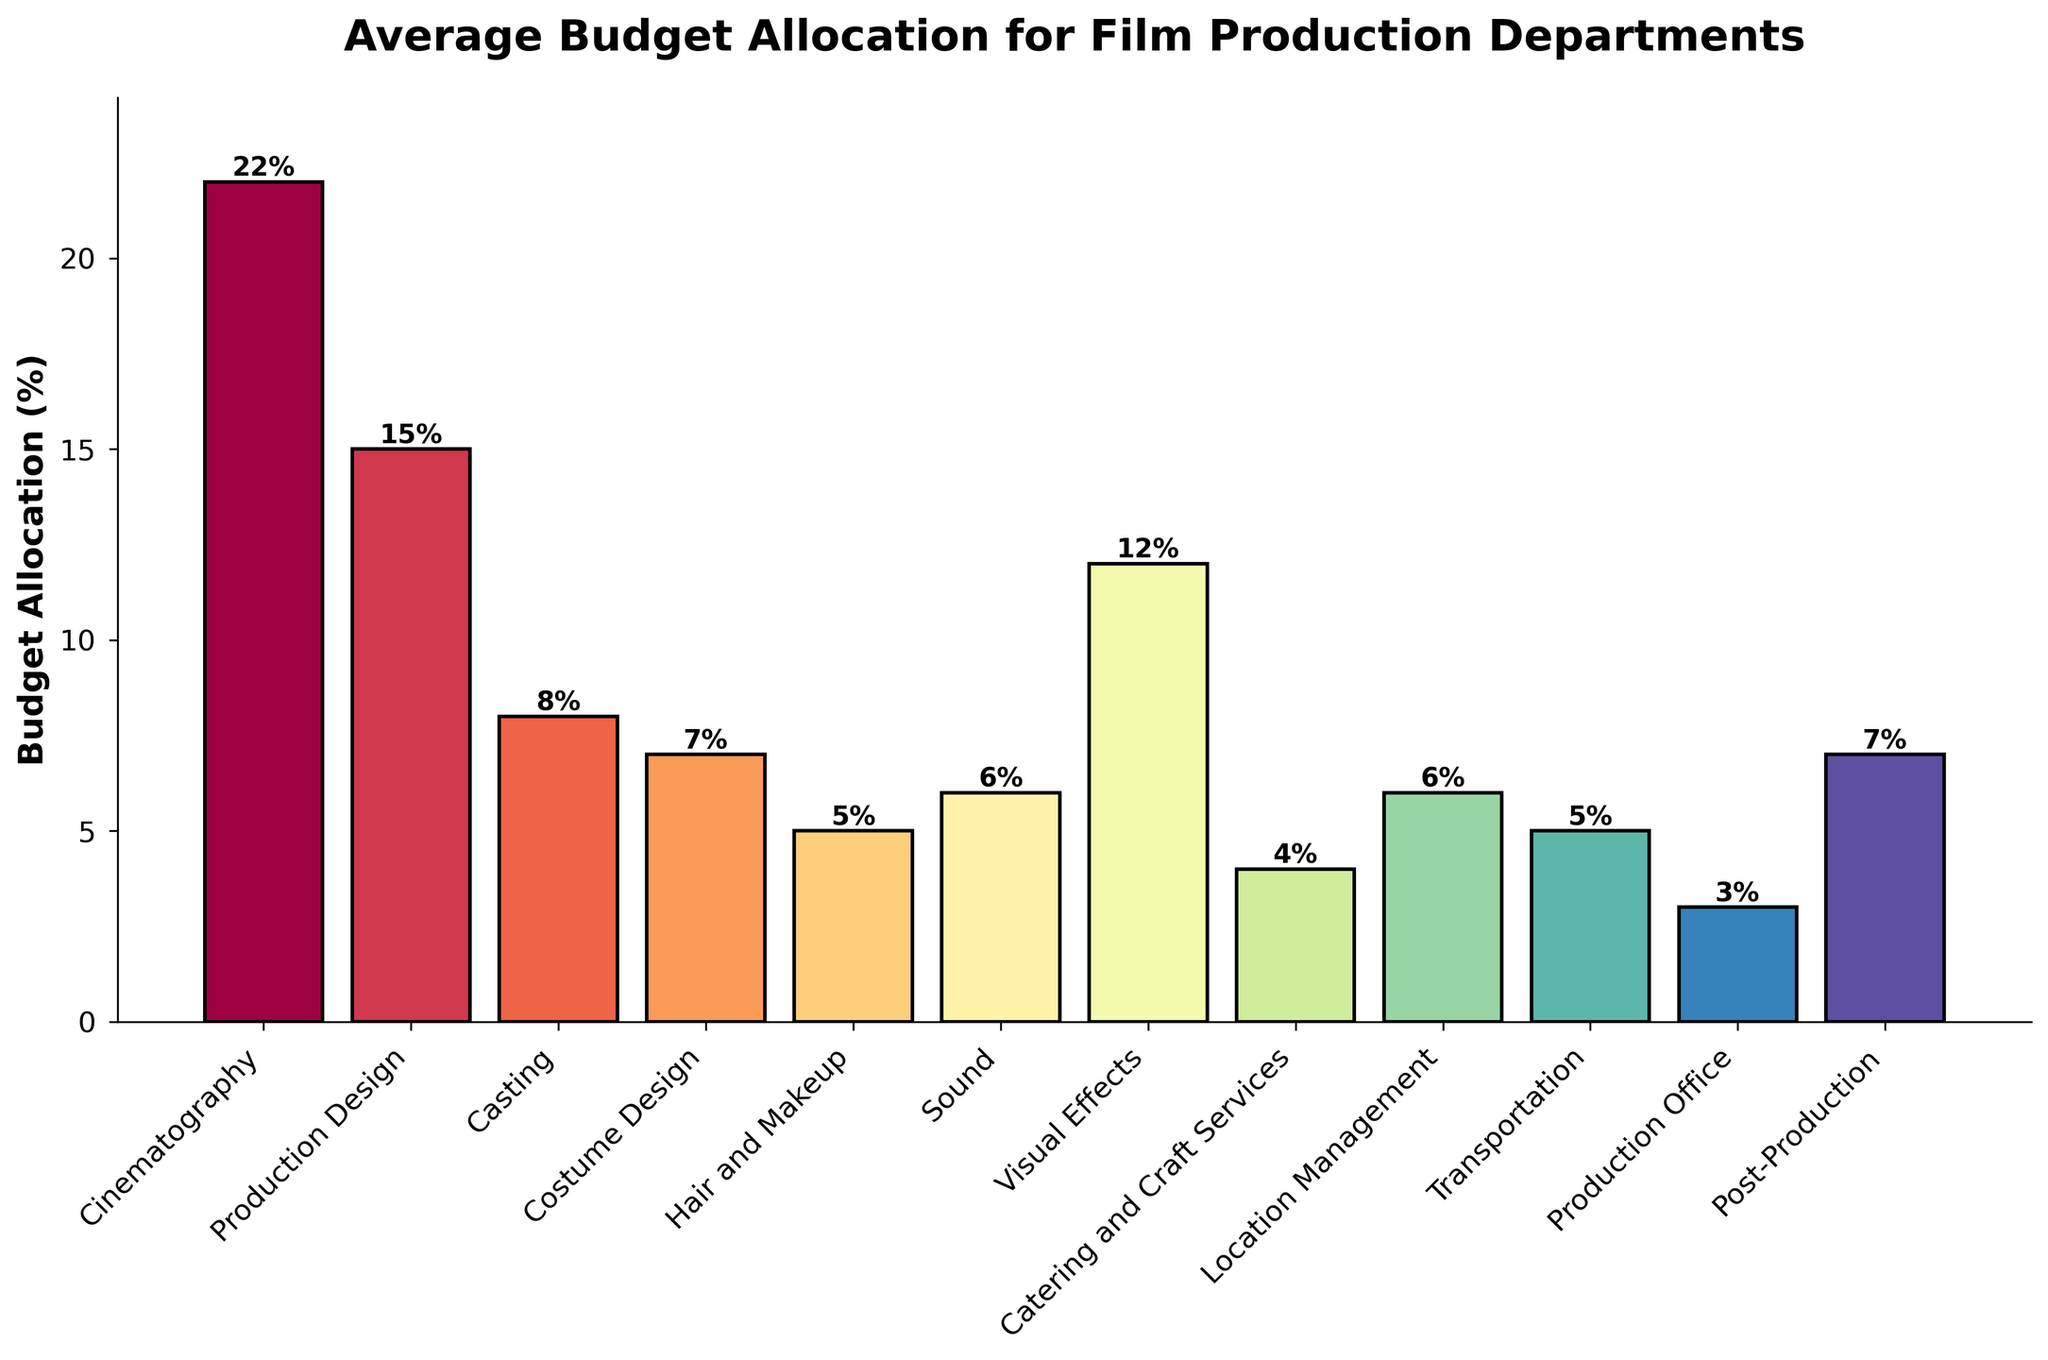Which department has the highest budget allocation percentage? The bar with the highest height represents the department with the largest budget allocation. The "Cinematography" department has the tallest bar at 22%.
Answer: Cinematography Which departments have a budget allocation greater than or equal to 10%? By looking at the bars that reach or exceed the 10% mark on the y-axis, we find that "Cinematography" (22%) and "Production Design" (15%) meet this criterion. "Visual Effects" also qualifies at 12%.
Answer: Cinematography, Production Design, Visual Effects What is the total budget percentage allocated to Costume Design, Hair and Makeup, and Sound combined? Add up the budget allocations for Costume Design (7%), Hair and Makeup (5%), and Sound (6%). 7 + 5 + 6 = 18.
Answer: 18% Is the budget for Catering and Craft Services higher than the budget for Production Office? Compare the heights of the bars representing Catering and Craft Services (4%) and Production Office (3%). Catering and Craft Services has a higher budget.
Answer: Yes Which department has the lowest budget allocation and what is it? Identify the bar with the shortest height. The "Production Office" has the lowest budget allocation at 3%.
Answer: Production Office, 3% How much higher is the budget percentage for Casting compared to Location Management? Subtract the budget for Location Management (6%) from Casting (8%). 8 - 6 = 2.
Answer: 2% What is the average budget allocation for the departments that have less than a 6% budget allocation? Identify the departments (Hair and Makeup 5%, Catering and Craft Services 4%, Transportation 5%, and Production Office 3%), sum their percentages (5 + 4 + 5 + 3 = 17), and divide by the number of departments (4). 17 / 4 = 4.25.
Answer: 4.25% What is the combined budget percentage for departments involved in visual aspects (Cinematography, Production Design, and Visual Effects)? Sum the percentages for Cinematography (22%), Production Design (15%), and Visual Effects (12%). 22 + 15 + 12 = 49.
Answer: 49% How does the budget for Location Management compare to the budget for Costume Design? Compare the heights of the bars for Location Management (6%) and Costume Design (7%). Costume Design has a higher budget.
Answer: Location Management < Costume Design 